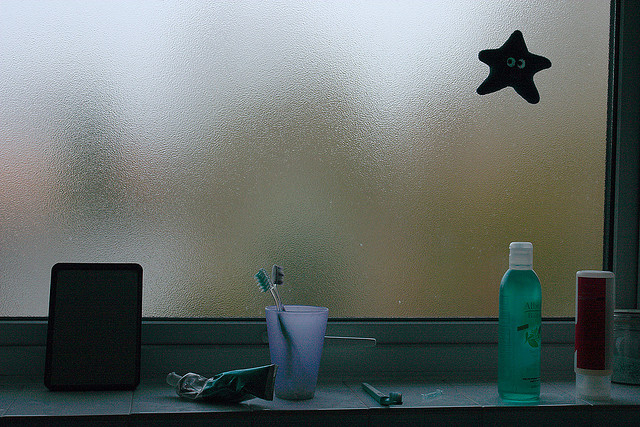What does the presence of multiple toothbrushes suggest about the people who might use this bathroom? The multiple toothbrushes typically indicate that the bathroom is shared among several individuals. This can suggest a family, roommates, or guests frequently using the space, highlighting a communal and possibly intimate dynamic among the users. The arrangement offers a glimpse into their daily life and interpersonal relationships. 